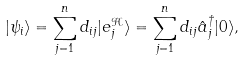Convert formula to latex. <formula><loc_0><loc_0><loc_500><loc_500>| \psi _ { i } \rangle = \sum _ { j = 1 } ^ { n } d _ { i j } | e _ { j } ^ { \mathcal { H } } \rangle = \sum _ { j = 1 } ^ { n } d _ { i j } \hat { a } _ { j } ^ { \dagger } | 0 \rangle ,</formula> 